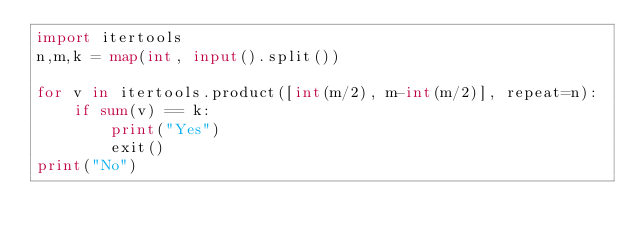<code> <loc_0><loc_0><loc_500><loc_500><_Python_>import itertools
n,m,k = map(int, input().split())

for v in itertools.product([int(m/2), m-int(m/2)], repeat=n):
    if sum(v) == k: 
        print("Yes")
        exit()
print("No")</code> 